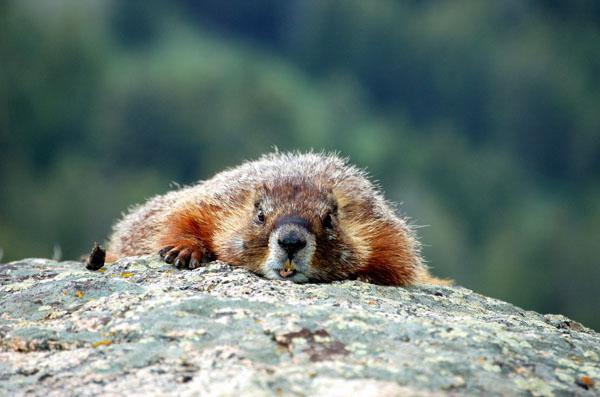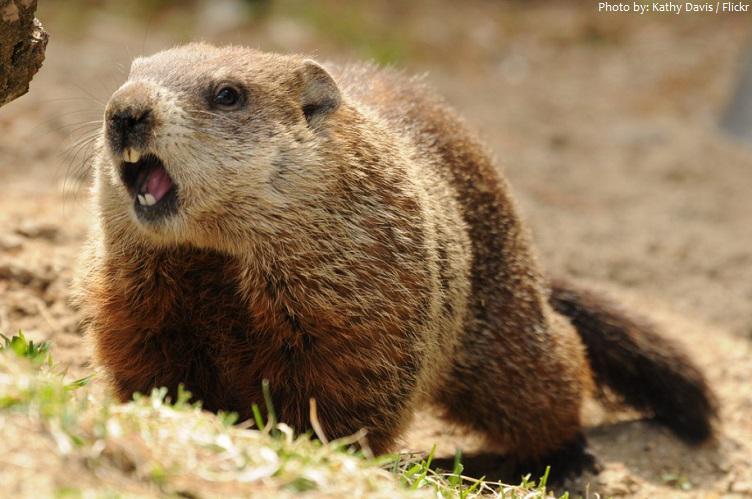The first image is the image on the left, the second image is the image on the right. For the images displayed, is the sentence "There are only 2 marmots." factually correct? Answer yes or no. Yes. 